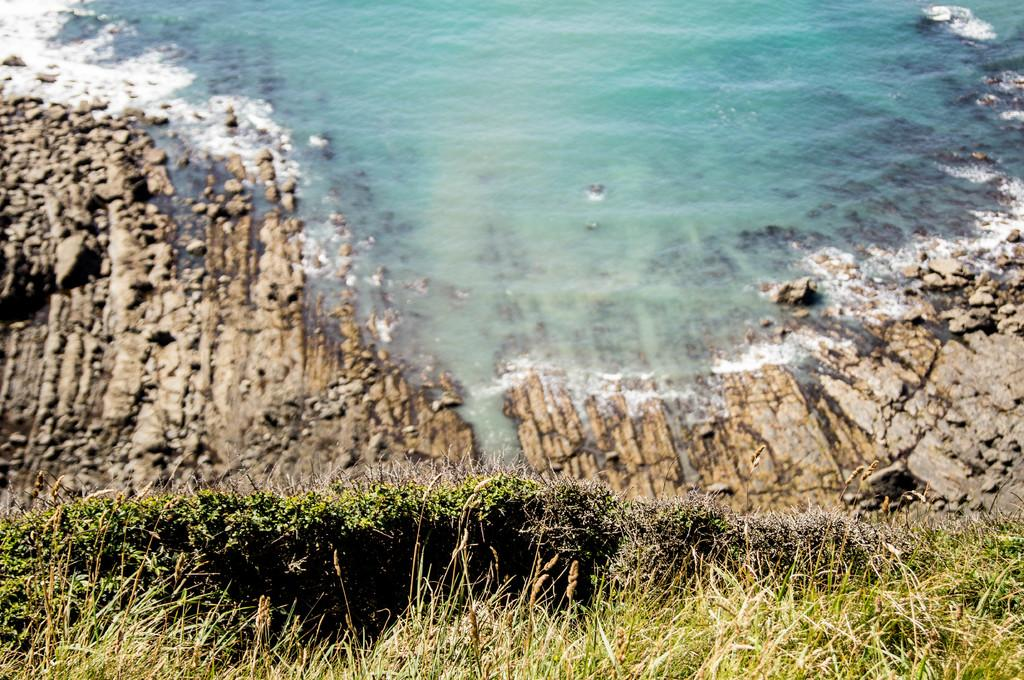What type of living organisms can be seen in the image? Plants can be seen in the image. What color are the plants in the image? The plants are green in color. What can be seen in the background of the image? Rocks are visible in the background of the image. What else is visible in the image besides the plants and rocks? There is water visible in the image. What type of bomb can be seen in the image? There is no bomb present in the image; it features plants, rocks, and water. How many trucks are visible in the image? There are no trucks present in the image. 